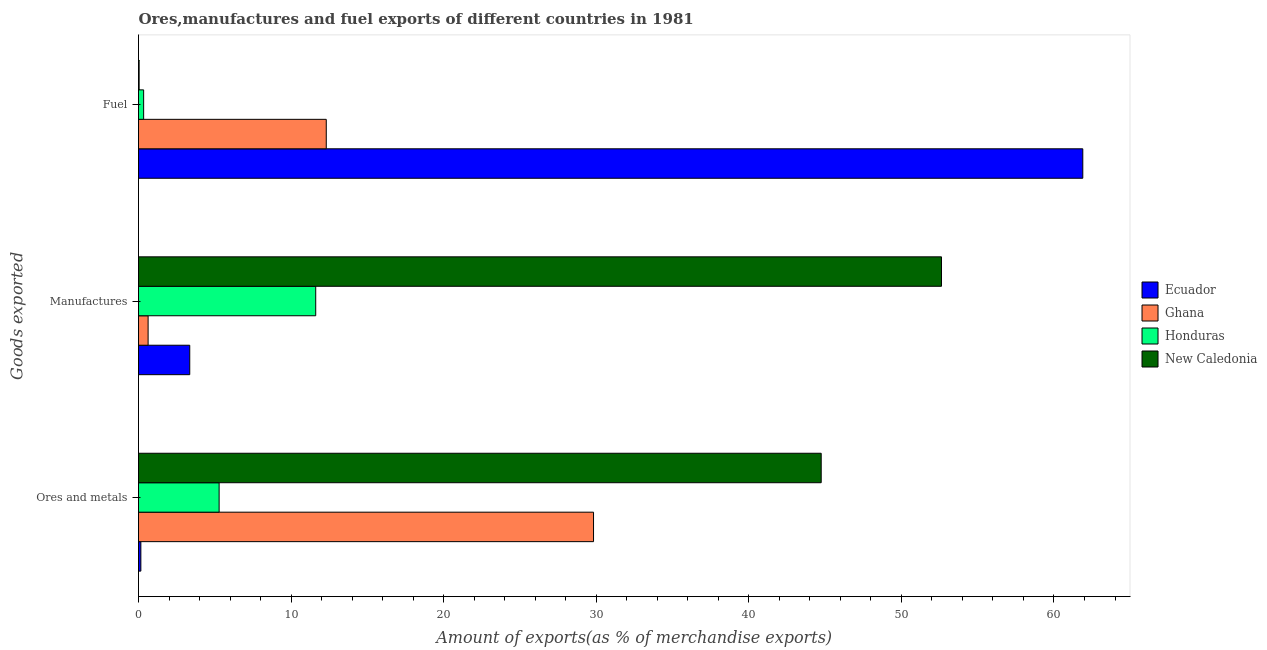How many different coloured bars are there?
Provide a short and direct response. 4. How many groups of bars are there?
Provide a short and direct response. 3. How many bars are there on the 3rd tick from the bottom?
Give a very brief answer. 4. What is the label of the 1st group of bars from the top?
Your response must be concise. Fuel. What is the percentage of manufactures exports in Ghana?
Keep it short and to the point. 0.63. Across all countries, what is the maximum percentage of manufactures exports?
Keep it short and to the point. 52.63. Across all countries, what is the minimum percentage of manufactures exports?
Offer a terse response. 0.63. In which country was the percentage of manufactures exports maximum?
Offer a very short reply. New Caledonia. In which country was the percentage of fuel exports minimum?
Offer a terse response. New Caledonia. What is the total percentage of fuel exports in the graph?
Your answer should be very brief. 74.57. What is the difference between the percentage of manufactures exports in Ecuador and that in New Caledonia?
Provide a succinct answer. -49.27. What is the difference between the percentage of fuel exports in Honduras and the percentage of manufactures exports in Ecuador?
Give a very brief answer. -3.02. What is the average percentage of manufactures exports per country?
Offer a terse response. 17.06. What is the difference between the percentage of ores and metals exports and percentage of manufactures exports in Honduras?
Offer a terse response. -6.33. In how many countries, is the percentage of ores and metals exports greater than 34 %?
Make the answer very short. 1. What is the ratio of the percentage of manufactures exports in New Caledonia to that in Ghana?
Give a very brief answer. 83.61. Is the percentage of manufactures exports in Ghana less than that in Honduras?
Your response must be concise. Yes. What is the difference between the highest and the second highest percentage of manufactures exports?
Make the answer very short. 41.01. What is the difference between the highest and the lowest percentage of fuel exports?
Provide a short and direct response. 61.85. In how many countries, is the percentage of ores and metals exports greater than the average percentage of ores and metals exports taken over all countries?
Ensure brevity in your answer.  2. What does the 4th bar from the bottom in Manufactures represents?
Ensure brevity in your answer.  New Caledonia. How many bars are there?
Ensure brevity in your answer.  12. How many countries are there in the graph?
Ensure brevity in your answer.  4. Does the graph contain any zero values?
Offer a terse response. No. Where does the legend appear in the graph?
Offer a very short reply. Center right. What is the title of the graph?
Give a very brief answer. Ores,manufactures and fuel exports of different countries in 1981. What is the label or title of the X-axis?
Keep it short and to the point. Amount of exports(as % of merchandise exports). What is the label or title of the Y-axis?
Keep it short and to the point. Goods exported. What is the Amount of exports(as % of merchandise exports) in Ecuador in Ores and metals?
Provide a short and direct response. 0.15. What is the Amount of exports(as % of merchandise exports) of Ghana in Ores and metals?
Your answer should be very brief. 29.82. What is the Amount of exports(as % of merchandise exports) of Honduras in Ores and metals?
Keep it short and to the point. 5.28. What is the Amount of exports(as % of merchandise exports) of New Caledonia in Ores and metals?
Provide a short and direct response. 44.74. What is the Amount of exports(as % of merchandise exports) in Ecuador in Manufactures?
Ensure brevity in your answer.  3.36. What is the Amount of exports(as % of merchandise exports) in Ghana in Manufactures?
Ensure brevity in your answer.  0.63. What is the Amount of exports(as % of merchandise exports) in Honduras in Manufactures?
Make the answer very short. 11.61. What is the Amount of exports(as % of merchandise exports) of New Caledonia in Manufactures?
Offer a terse response. 52.63. What is the Amount of exports(as % of merchandise exports) of Ecuador in Fuel?
Offer a very short reply. 61.89. What is the Amount of exports(as % of merchandise exports) of Ghana in Fuel?
Provide a short and direct response. 12.31. What is the Amount of exports(as % of merchandise exports) in Honduras in Fuel?
Your answer should be compact. 0.34. What is the Amount of exports(as % of merchandise exports) of New Caledonia in Fuel?
Offer a terse response. 0.04. Across all Goods exported, what is the maximum Amount of exports(as % of merchandise exports) in Ecuador?
Your response must be concise. 61.89. Across all Goods exported, what is the maximum Amount of exports(as % of merchandise exports) of Ghana?
Make the answer very short. 29.82. Across all Goods exported, what is the maximum Amount of exports(as % of merchandise exports) in Honduras?
Offer a terse response. 11.61. Across all Goods exported, what is the maximum Amount of exports(as % of merchandise exports) of New Caledonia?
Provide a short and direct response. 52.63. Across all Goods exported, what is the minimum Amount of exports(as % of merchandise exports) of Ecuador?
Offer a very short reply. 0.15. Across all Goods exported, what is the minimum Amount of exports(as % of merchandise exports) in Ghana?
Your answer should be very brief. 0.63. Across all Goods exported, what is the minimum Amount of exports(as % of merchandise exports) in Honduras?
Your response must be concise. 0.34. Across all Goods exported, what is the minimum Amount of exports(as % of merchandise exports) in New Caledonia?
Your answer should be compact. 0.04. What is the total Amount of exports(as % of merchandise exports) in Ecuador in the graph?
Offer a very short reply. 65.4. What is the total Amount of exports(as % of merchandise exports) of Ghana in the graph?
Keep it short and to the point. 42.76. What is the total Amount of exports(as % of merchandise exports) of Honduras in the graph?
Keep it short and to the point. 17.23. What is the total Amount of exports(as % of merchandise exports) of New Caledonia in the graph?
Your response must be concise. 97.41. What is the difference between the Amount of exports(as % of merchandise exports) of Ecuador in Ores and metals and that in Manufactures?
Provide a succinct answer. -3.2. What is the difference between the Amount of exports(as % of merchandise exports) of Ghana in Ores and metals and that in Manufactures?
Offer a very short reply. 29.19. What is the difference between the Amount of exports(as % of merchandise exports) of Honduras in Ores and metals and that in Manufactures?
Your response must be concise. -6.33. What is the difference between the Amount of exports(as % of merchandise exports) of New Caledonia in Ores and metals and that in Manufactures?
Provide a short and direct response. -7.88. What is the difference between the Amount of exports(as % of merchandise exports) in Ecuador in Ores and metals and that in Fuel?
Offer a very short reply. -61.74. What is the difference between the Amount of exports(as % of merchandise exports) in Ghana in Ores and metals and that in Fuel?
Give a very brief answer. 17.52. What is the difference between the Amount of exports(as % of merchandise exports) of Honduras in Ores and metals and that in Fuel?
Your response must be concise. 4.95. What is the difference between the Amount of exports(as % of merchandise exports) of New Caledonia in Ores and metals and that in Fuel?
Make the answer very short. 44.7. What is the difference between the Amount of exports(as % of merchandise exports) in Ecuador in Manufactures and that in Fuel?
Your answer should be compact. -58.53. What is the difference between the Amount of exports(as % of merchandise exports) in Ghana in Manufactures and that in Fuel?
Ensure brevity in your answer.  -11.68. What is the difference between the Amount of exports(as % of merchandise exports) in Honduras in Manufactures and that in Fuel?
Your answer should be compact. 11.28. What is the difference between the Amount of exports(as % of merchandise exports) of New Caledonia in Manufactures and that in Fuel?
Provide a short and direct response. 52.59. What is the difference between the Amount of exports(as % of merchandise exports) in Ecuador in Ores and metals and the Amount of exports(as % of merchandise exports) in Ghana in Manufactures?
Offer a very short reply. -0.48. What is the difference between the Amount of exports(as % of merchandise exports) in Ecuador in Ores and metals and the Amount of exports(as % of merchandise exports) in Honduras in Manufactures?
Make the answer very short. -11.46. What is the difference between the Amount of exports(as % of merchandise exports) in Ecuador in Ores and metals and the Amount of exports(as % of merchandise exports) in New Caledonia in Manufactures?
Offer a very short reply. -52.47. What is the difference between the Amount of exports(as % of merchandise exports) in Ghana in Ores and metals and the Amount of exports(as % of merchandise exports) in Honduras in Manufactures?
Your answer should be very brief. 18.21. What is the difference between the Amount of exports(as % of merchandise exports) of Ghana in Ores and metals and the Amount of exports(as % of merchandise exports) of New Caledonia in Manufactures?
Ensure brevity in your answer.  -22.81. What is the difference between the Amount of exports(as % of merchandise exports) of Honduras in Ores and metals and the Amount of exports(as % of merchandise exports) of New Caledonia in Manufactures?
Make the answer very short. -47.34. What is the difference between the Amount of exports(as % of merchandise exports) of Ecuador in Ores and metals and the Amount of exports(as % of merchandise exports) of Ghana in Fuel?
Your answer should be very brief. -12.15. What is the difference between the Amount of exports(as % of merchandise exports) in Ecuador in Ores and metals and the Amount of exports(as % of merchandise exports) in Honduras in Fuel?
Ensure brevity in your answer.  -0.18. What is the difference between the Amount of exports(as % of merchandise exports) in Ecuador in Ores and metals and the Amount of exports(as % of merchandise exports) in New Caledonia in Fuel?
Keep it short and to the point. 0.11. What is the difference between the Amount of exports(as % of merchandise exports) of Ghana in Ores and metals and the Amount of exports(as % of merchandise exports) of Honduras in Fuel?
Offer a very short reply. 29.49. What is the difference between the Amount of exports(as % of merchandise exports) in Ghana in Ores and metals and the Amount of exports(as % of merchandise exports) in New Caledonia in Fuel?
Your response must be concise. 29.78. What is the difference between the Amount of exports(as % of merchandise exports) of Honduras in Ores and metals and the Amount of exports(as % of merchandise exports) of New Caledonia in Fuel?
Your response must be concise. 5.24. What is the difference between the Amount of exports(as % of merchandise exports) of Ecuador in Manufactures and the Amount of exports(as % of merchandise exports) of Ghana in Fuel?
Your answer should be compact. -8.95. What is the difference between the Amount of exports(as % of merchandise exports) of Ecuador in Manufactures and the Amount of exports(as % of merchandise exports) of Honduras in Fuel?
Your response must be concise. 3.02. What is the difference between the Amount of exports(as % of merchandise exports) of Ecuador in Manufactures and the Amount of exports(as % of merchandise exports) of New Caledonia in Fuel?
Your response must be concise. 3.32. What is the difference between the Amount of exports(as % of merchandise exports) of Ghana in Manufactures and the Amount of exports(as % of merchandise exports) of Honduras in Fuel?
Make the answer very short. 0.29. What is the difference between the Amount of exports(as % of merchandise exports) in Ghana in Manufactures and the Amount of exports(as % of merchandise exports) in New Caledonia in Fuel?
Provide a short and direct response. 0.59. What is the difference between the Amount of exports(as % of merchandise exports) of Honduras in Manufactures and the Amount of exports(as % of merchandise exports) of New Caledonia in Fuel?
Keep it short and to the point. 11.57. What is the average Amount of exports(as % of merchandise exports) of Ecuador per Goods exported?
Ensure brevity in your answer.  21.8. What is the average Amount of exports(as % of merchandise exports) of Ghana per Goods exported?
Your response must be concise. 14.25. What is the average Amount of exports(as % of merchandise exports) of Honduras per Goods exported?
Make the answer very short. 5.74. What is the average Amount of exports(as % of merchandise exports) in New Caledonia per Goods exported?
Offer a terse response. 32.47. What is the difference between the Amount of exports(as % of merchandise exports) of Ecuador and Amount of exports(as % of merchandise exports) of Ghana in Ores and metals?
Your response must be concise. -29.67. What is the difference between the Amount of exports(as % of merchandise exports) of Ecuador and Amount of exports(as % of merchandise exports) of Honduras in Ores and metals?
Offer a very short reply. -5.13. What is the difference between the Amount of exports(as % of merchandise exports) of Ecuador and Amount of exports(as % of merchandise exports) of New Caledonia in Ores and metals?
Your answer should be compact. -44.59. What is the difference between the Amount of exports(as % of merchandise exports) in Ghana and Amount of exports(as % of merchandise exports) in Honduras in Ores and metals?
Your response must be concise. 24.54. What is the difference between the Amount of exports(as % of merchandise exports) of Ghana and Amount of exports(as % of merchandise exports) of New Caledonia in Ores and metals?
Keep it short and to the point. -14.92. What is the difference between the Amount of exports(as % of merchandise exports) of Honduras and Amount of exports(as % of merchandise exports) of New Caledonia in Ores and metals?
Keep it short and to the point. -39.46. What is the difference between the Amount of exports(as % of merchandise exports) of Ecuador and Amount of exports(as % of merchandise exports) of Ghana in Manufactures?
Your response must be concise. 2.73. What is the difference between the Amount of exports(as % of merchandise exports) of Ecuador and Amount of exports(as % of merchandise exports) of Honduras in Manufactures?
Your answer should be compact. -8.26. What is the difference between the Amount of exports(as % of merchandise exports) of Ecuador and Amount of exports(as % of merchandise exports) of New Caledonia in Manufactures?
Keep it short and to the point. -49.27. What is the difference between the Amount of exports(as % of merchandise exports) of Ghana and Amount of exports(as % of merchandise exports) of Honduras in Manufactures?
Your response must be concise. -10.99. What is the difference between the Amount of exports(as % of merchandise exports) in Ghana and Amount of exports(as % of merchandise exports) in New Caledonia in Manufactures?
Your answer should be compact. -52. What is the difference between the Amount of exports(as % of merchandise exports) of Honduras and Amount of exports(as % of merchandise exports) of New Caledonia in Manufactures?
Provide a short and direct response. -41.01. What is the difference between the Amount of exports(as % of merchandise exports) in Ecuador and Amount of exports(as % of merchandise exports) in Ghana in Fuel?
Make the answer very short. 49.58. What is the difference between the Amount of exports(as % of merchandise exports) in Ecuador and Amount of exports(as % of merchandise exports) in Honduras in Fuel?
Offer a very short reply. 61.55. What is the difference between the Amount of exports(as % of merchandise exports) in Ecuador and Amount of exports(as % of merchandise exports) in New Caledonia in Fuel?
Offer a very short reply. 61.85. What is the difference between the Amount of exports(as % of merchandise exports) in Ghana and Amount of exports(as % of merchandise exports) in Honduras in Fuel?
Ensure brevity in your answer.  11.97. What is the difference between the Amount of exports(as % of merchandise exports) in Ghana and Amount of exports(as % of merchandise exports) in New Caledonia in Fuel?
Your answer should be very brief. 12.27. What is the difference between the Amount of exports(as % of merchandise exports) of Honduras and Amount of exports(as % of merchandise exports) of New Caledonia in Fuel?
Offer a terse response. 0.29. What is the ratio of the Amount of exports(as % of merchandise exports) in Ecuador in Ores and metals to that in Manufactures?
Provide a succinct answer. 0.05. What is the ratio of the Amount of exports(as % of merchandise exports) of Ghana in Ores and metals to that in Manufactures?
Your response must be concise. 47.38. What is the ratio of the Amount of exports(as % of merchandise exports) in Honduras in Ores and metals to that in Manufactures?
Give a very brief answer. 0.45. What is the ratio of the Amount of exports(as % of merchandise exports) of New Caledonia in Ores and metals to that in Manufactures?
Provide a succinct answer. 0.85. What is the ratio of the Amount of exports(as % of merchandise exports) of Ecuador in Ores and metals to that in Fuel?
Offer a very short reply. 0. What is the ratio of the Amount of exports(as % of merchandise exports) of Ghana in Ores and metals to that in Fuel?
Make the answer very short. 2.42. What is the ratio of the Amount of exports(as % of merchandise exports) in Honduras in Ores and metals to that in Fuel?
Make the answer very short. 15.73. What is the ratio of the Amount of exports(as % of merchandise exports) in New Caledonia in Ores and metals to that in Fuel?
Offer a very short reply. 1093.49. What is the ratio of the Amount of exports(as % of merchandise exports) in Ecuador in Manufactures to that in Fuel?
Offer a terse response. 0.05. What is the ratio of the Amount of exports(as % of merchandise exports) in Ghana in Manufactures to that in Fuel?
Your answer should be very brief. 0.05. What is the ratio of the Amount of exports(as % of merchandise exports) of Honduras in Manufactures to that in Fuel?
Your answer should be compact. 34.57. What is the ratio of the Amount of exports(as % of merchandise exports) of New Caledonia in Manufactures to that in Fuel?
Give a very brief answer. 1286.16. What is the difference between the highest and the second highest Amount of exports(as % of merchandise exports) of Ecuador?
Your response must be concise. 58.53. What is the difference between the highest and the second highest Amount of exports(as % of merchandise exports) in Ghana?
Keep it short and to the point. 17.52. What is the difference between the highest and the second highest Amount of exports(as % of merchandise exports) of Honduras?
Offer a terse response. 6.33. What is the difference between the highest and the second highest Amount of exports(as % of merchandise exports) in New Caledonia?
Make the answer very short. 7.88. What is the difference between the highest and the lowest Amount of exports(as % of merchandise exports) of Ecuador?
Your answer should be very brief. 61.74. What is the difference between the highest and the lowest Amount of exports(as % of merchandise exports) of Ghana?
Keep it short and to the point. 29.19. What is the difference between the highest and the lowest Amount of exports(as % of merchandise exports) of Honduras?
Provide a short and direct response. 11.28. What is the difference between the highest and the lowest Amount of exports(as % of merchandise exports) in New Caledonia?
Give a very brief answer. 52.59. 